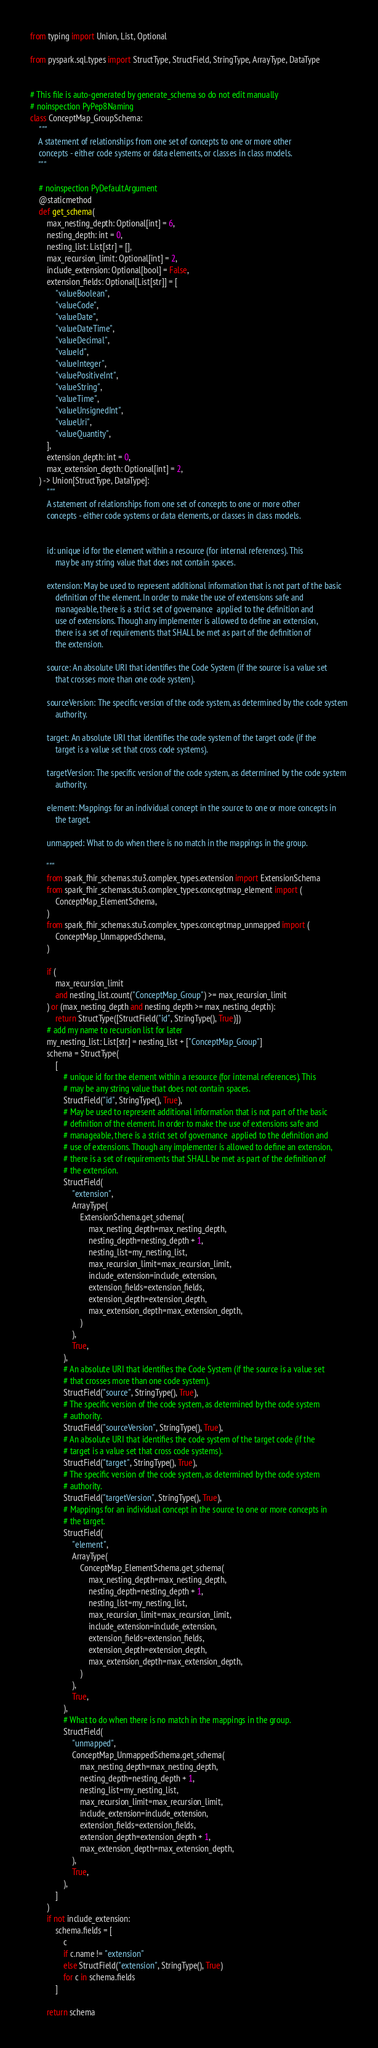<code> <loc_0><loc_0><loc_500><loc_500><_Python_>from typing import Union, List, Optional

from pyspark.sql.types import StructType, StructField, StringType, ArrayType, DataType


# This file is auto-generated by generate_schema so do not edit manually
# noinspection PyPep8Naming
class ConceptMap_GroupSchema:
    """
    A statement of relationships from one set of concepts to one or more other
    concepts - either code systems or data elements, or classes in class models.
    """

    # noinspection PyDefaultArgument
    @staticmethod
    def get_schema(
        max_nesting_depth: Optional[int] = 6,
        nesting_depth: int = 0,
        nesting_list: List[str] = [],
        max_recursion_limit: Optional[int] = 2,
        include_extension: Optional[bool] = False,
        extension_fields: Optional[List[str]] = [
            "valueBoolean",
            "valueCode",
            "valueDate",
            "valueDateTime",
            "valueDecimal",
            "valueId",
            "valueInteger",
            "valuePositiveInt",
            "valueString",
            "valueTime",
            "valueUnsignedInt",
            "valueUri",
            "valueQuantity",
        ],
        extension_depth: int = 0,
        max_extension_depth: Optional[int] = 2,
    ) -> Union[StructType, DataType]:
        """
        A statement of relationships from one set of concepts to one or more other
        concepts - either code systems or data elements, or classes in class models.


        id: unique id for the element within a resource (for internal references). This
            may be any string value that does not contain spaces.

        extension: May be used to represent additional information that is not part of the basic
            definition of the element. In order to make the use of extensions safe and
            manageable, there is a strict set of governance  applied to the definition and
            use of extensions. Though any implementer is allowed to define an extension,
            there is a set of requirements that SHALL be met as part of the definition of
            the extension.

        source: An absolute URI that identifies the Code System (if the source is a value set
            that crosses more than one code system).

        sourceVersion: The specific version of the code system, as determined by the code system
            authority.

        target: An absolute URI that identifies the code system of the target code (if the
            target is a value set that cross code systems).

        targetVersion: The specific version of the code system, as determined by the code system
            authority.

        element: Mappings for an individual concept in the source to one or more concepts in
            the target.

        unmapped: What to do when there is no match in the mappings in the group.

        """
        from spark_fhir_schemas.stu3.complex_types.extension import ExtensionSchema
        from spark_fhir_schemas.stu3.complex_types.conceptmap_element import (
            ConceptMap_ElementSchema,
        )
        from spark_fhir_schemas.stu3.complex_types.conceptmap_unmapped import (
            ConceptMap_UnmappedSchema,
        )

        if (
            max_recursion_limit
            and nesting_list.count("ConceptMap_Group") >= max_recursion_limit
        ) or (max_nesting_depth and nesting_depth >= max_nesting_depth):
            return StructType([StructField("id", StringType(), True)])
        # add my name to recursion list for later
        my_nesting_list: List[str] = nesting_list + ["ConceptMap_Group"]
        schema = StructType(
            [
                # unique id for the element within a resource (for internal references). This
                # may be any string value that does not contain spaces.
                StructField("id", StringType(), True),
                # May be used to represent additional information that is not part of the basic
                # definition of the element. In order to make the use of extensions safe and
                # manageable, there is a strict set of governance  applied to the definition and
                # use of extensions. Though any implementer is allowed to define an extension,
                # there is a set of requirements that SHALL be met as part of the definition of
                # the extension.
                StructField(
                    "extension",
                    ArrayType(
                        ExtensionSchema.get_schema(
                            max_nesting_depth=max_nesting_depth,
                            nesting_depth=nesting_depth + 1,
                            nesting_list=my_nesting_list,
                            max_recursion_limit=max_recursion_limit,
                            include_extension=include_extension,
                            extension_fields=extension_fields,
                            extension_depth=extension_depth,
                            max_extension_depth=max_extension_depth,
                        )
                    ),
                    True,
                ),
                # An absolute URI that identifies the Code System (if the source is a value set
                # that crosses more than one code system).
                StructField("source", StringType(), True),
                # The specific version of the code system, as determined by the code system
                # authority.
                StructField("sourceVersion", StringType(), True),
                # An absolute URI that identifies the code system of the target code (if the
                # target is a value set that cross code systems).
                StructField("target", StringType(), True),
                # The specific version of the code system, as determined by the code system
                # authority.
                StructField("targetVersion", StringType(), True),
                # Mappings for an individual concept in the source to one or more concepts in
                # the target.
                StructField(
                    "element",
                    ArrayType(
                        ConceptMap_ElementSchema.get_schema(
                            max_nesting_depth=max_nesting_depth,
                            nesting_depth=nesting_depth + 1,
                            nesting_list=my_nesting_list,
                            max_recursion_limit=max_recursion_limit,
                            include_extension=include_extension,
                            extension_fields=extension_fields,
                            extension_depth=extension_depth,
                            max_extension_depth=max_extension_depth,
                        )
                    ),
                    True,
                ),
                # What to do when there is no match in the mappings in the group.
                StructField(
                    "unmapped",
                    ConceptMap_UnmappedSchema.get_schema(
                        max_nesting_depth=max_nesting_depth,
                        nesting_depth=nesting_depth + 1,
                        nesting_list=my_nesting_list,
                        max_recursion_limit=max_recursion_limit,
                        include_extension=include_extension,
                        extension_fields=extension_fields,
                        extension_depth=extension_depth + 1,
                        max_extension_depth=max_extension_depth,
                    ),
                    True,
                ),
            ]
        )
        if not include_extension:
            schema.fields = [
                c
                if c.name != "extension"
                else StructField("extension", StringType(), True)
                for c in schema.fields
            ]

        return schema
</code> 